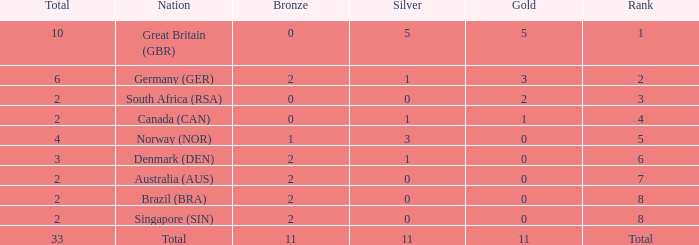What is the least total when the nation is canada (can) and bronze is less than 0? None. 